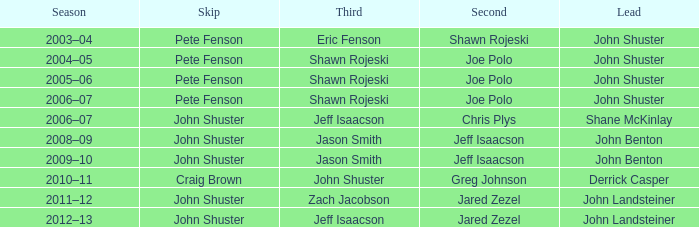Which season has Zach Jacobson in third? 2011–12. Can you give me this table as a dict? {'header': ['Season', 'Skip', 'Third', 'Second', 'Lead'], 'rows': [['2003–04', 'Pete Fenson', 'Eric Fenson', 'Shawn Rojeski', 'John Shuster'], ['2004–05', 'Pete Fenson', 'Shawn Rojeski', 'Joe Polo', 'John Shuster'], ['2005–06', 'Pete Fenson', 'Shawn Rojeski', 'Joe Polo', 'John Shuster'], ['2006–07', 'Pete Fenson', 'Shawn Rojeski', 'Joe Polo', 'John Shuster'], ['2006–07', 'John Shuster', 'Jeff Isaacson', 'Chris Plys', 'Shane McKinlay'], ['2008–09', 'John Shuster', 'Jason Smith', 'Jeff Isaacson', 'John Benton'], ['2009–10', 'John Shuster', 'Jason Smith', 'Jeff Isaacson', 'John Benton'], ['2010–11', 'Craig Brown', 'John Shuster', 'Greg Johnson', 'Derrick Casper'], ['2011–12', 'John Shuster', 'Zach Jacobson', 'Jared Zezel', 'John Landsteiner'], ['2012–13', 'John Shuster', 'Jeff Isaacson', 'Jared Zezel', 'John Landsteiner']]} 